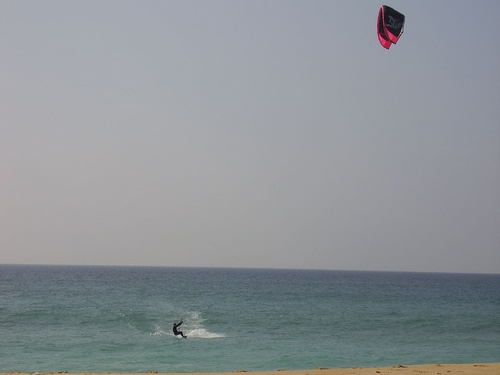Describe the objects in this image and their specific colors. I can see kite in darkgray, black, maroon, brown, and gray tones, people in darkgray, black, gray, and purple tones, and surfboard in darkgray and gray tones in this image. 